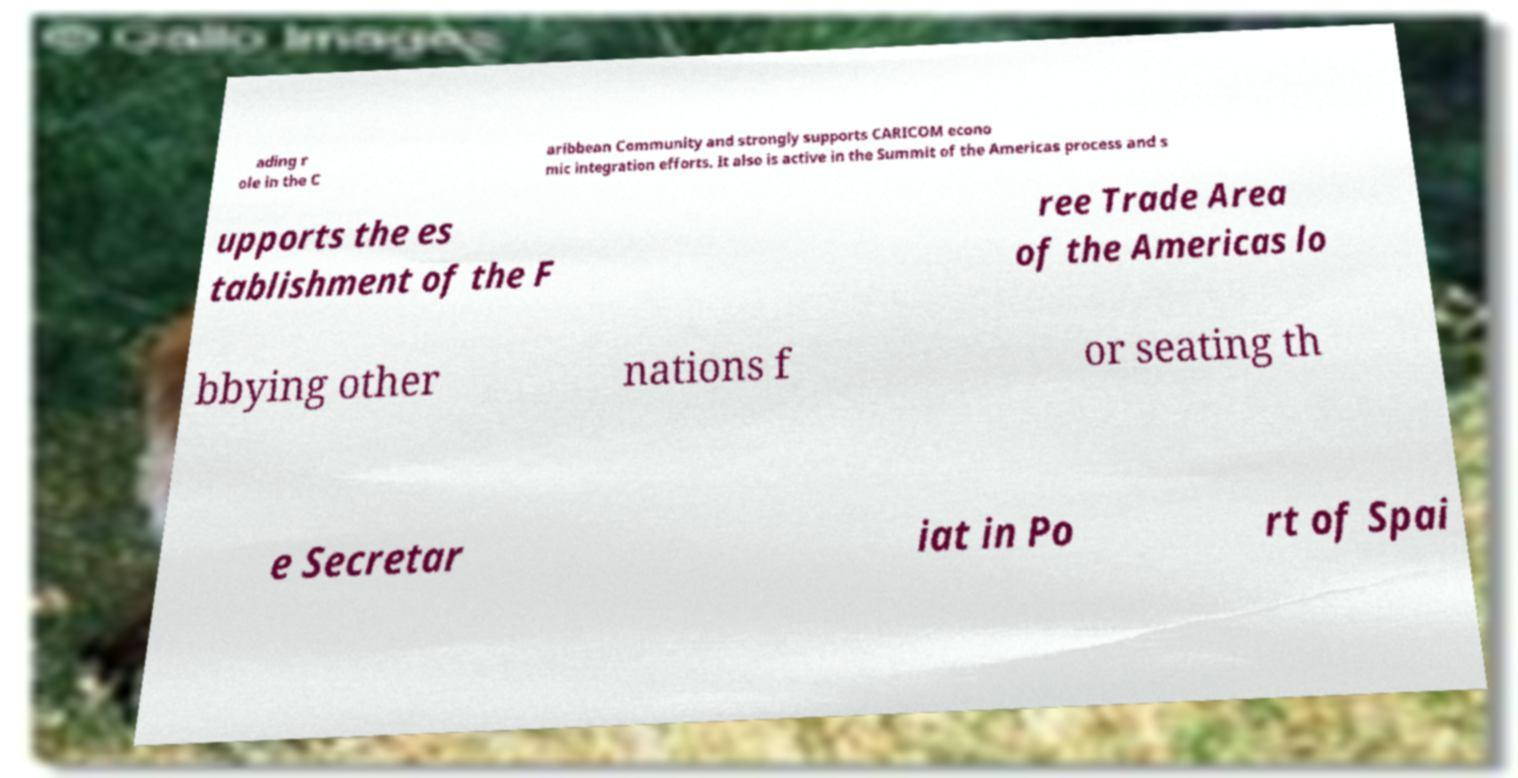Could you extract and type out the text from this image? ading r ole in the C aribbean Community and strongly supports CARICOM econo mic integration efforts. It also is active in the Summit of the Americas process and s upports the es tablishment of the F ree Trade Area of the Americas lo bbying other nations f or seating th e Secretar iat in Po rt of Spai 